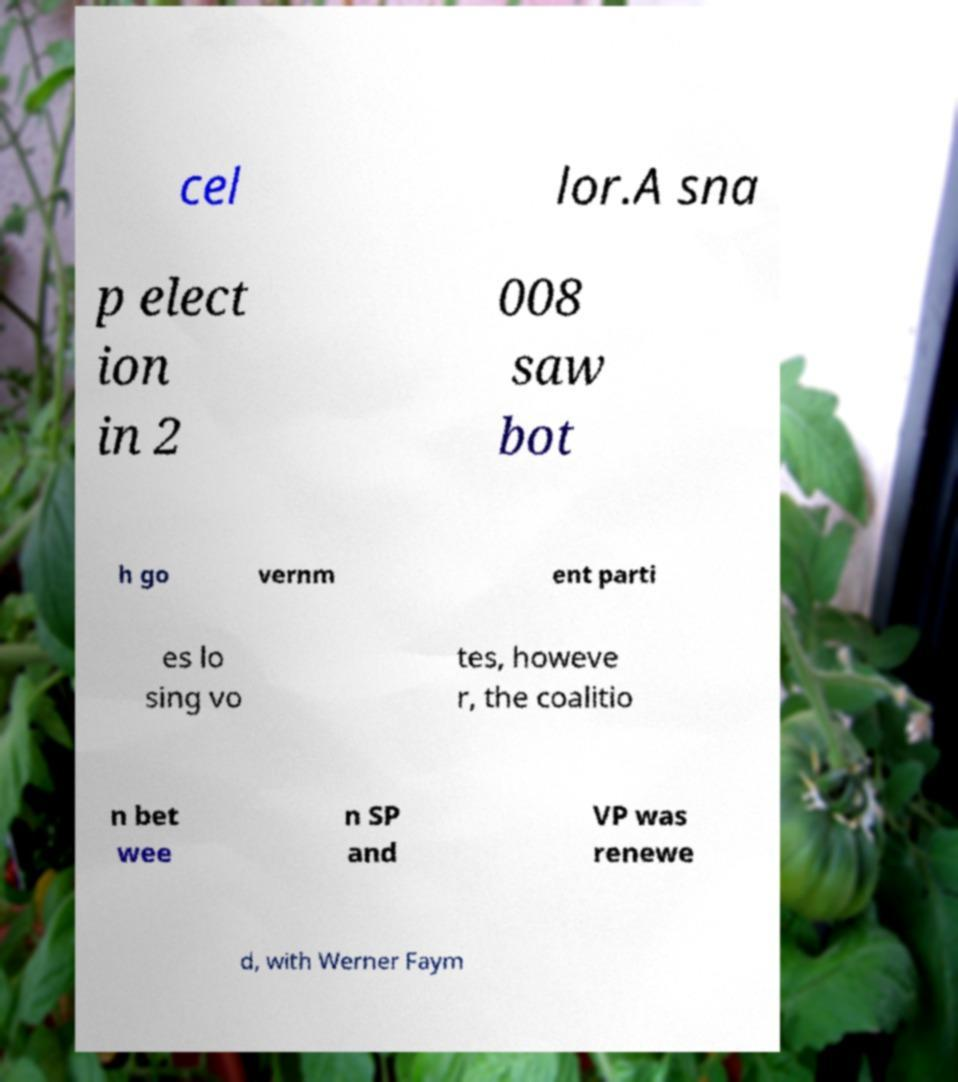What messages or text are displayed in this image? I need them in a readable, typed format. cel lor.A sna p elect ion in 2 008 saw bot h go vernm ent parti es lo sing vo tes, howeve r, the coalitio n bet wee n SP and VP was renewe d, with Werner Faym 